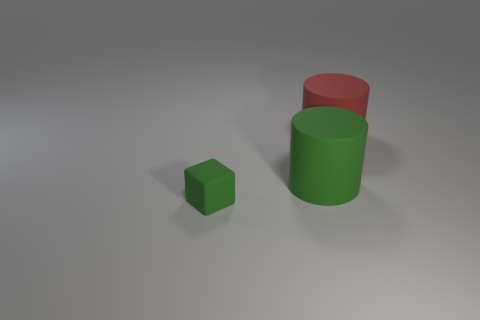Add 1 green blocks. How many objects exist? 4 Subtract all blocks. How many objects are left? 2 Subtract 0 brown cylinders. How many objects are left? 3 Subtract all big red spheres. Subtract all small green matte objects. How many objects are left? 2 Add 3 rubber objects. How many rubber objects are left? 6 Add 2 rubber things. How many rubber things exist? 5 